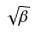Convert formula to latex. <formula><loc_0><loc_0><loc_500><loc_500>\sqrt { \beta }</formula> 